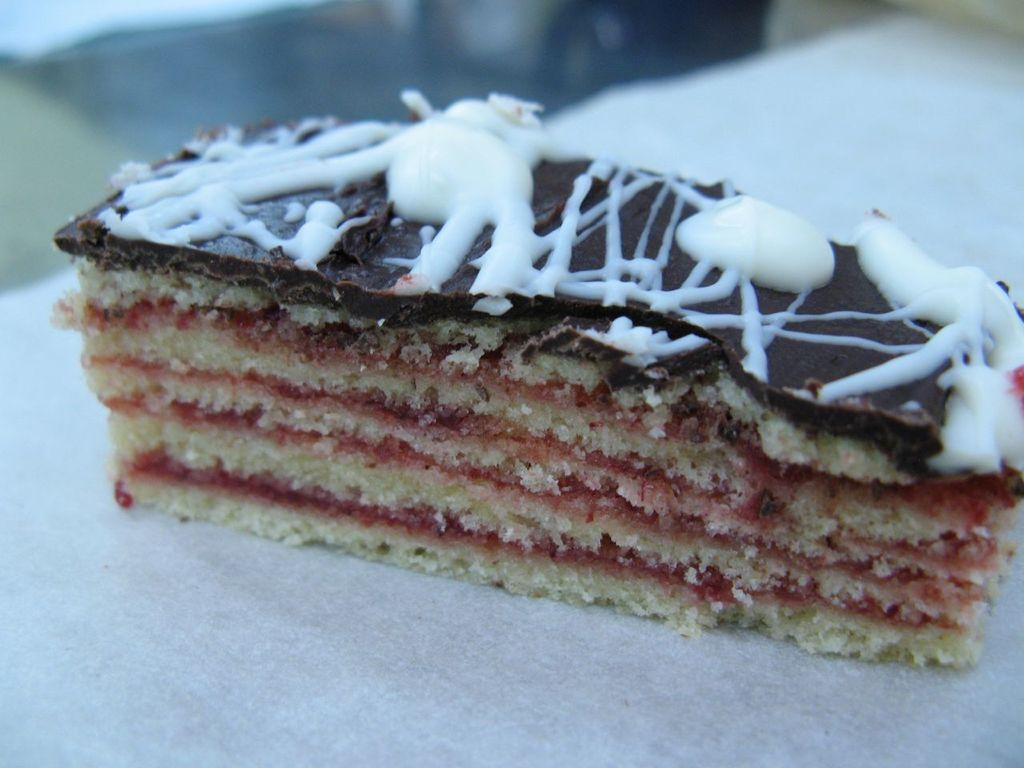What color is the surface that the food is placed on in the image? The surface is white. What is on the white surface in the image? There is food on the white surface. Can you describe the background of the image? The background of the image is blurred. What type of pipe is visible in the image? There is no pipe present in the image. Can you describe the tail of the animal in the image? There is no animal, and therefore no tail, present in the image. 